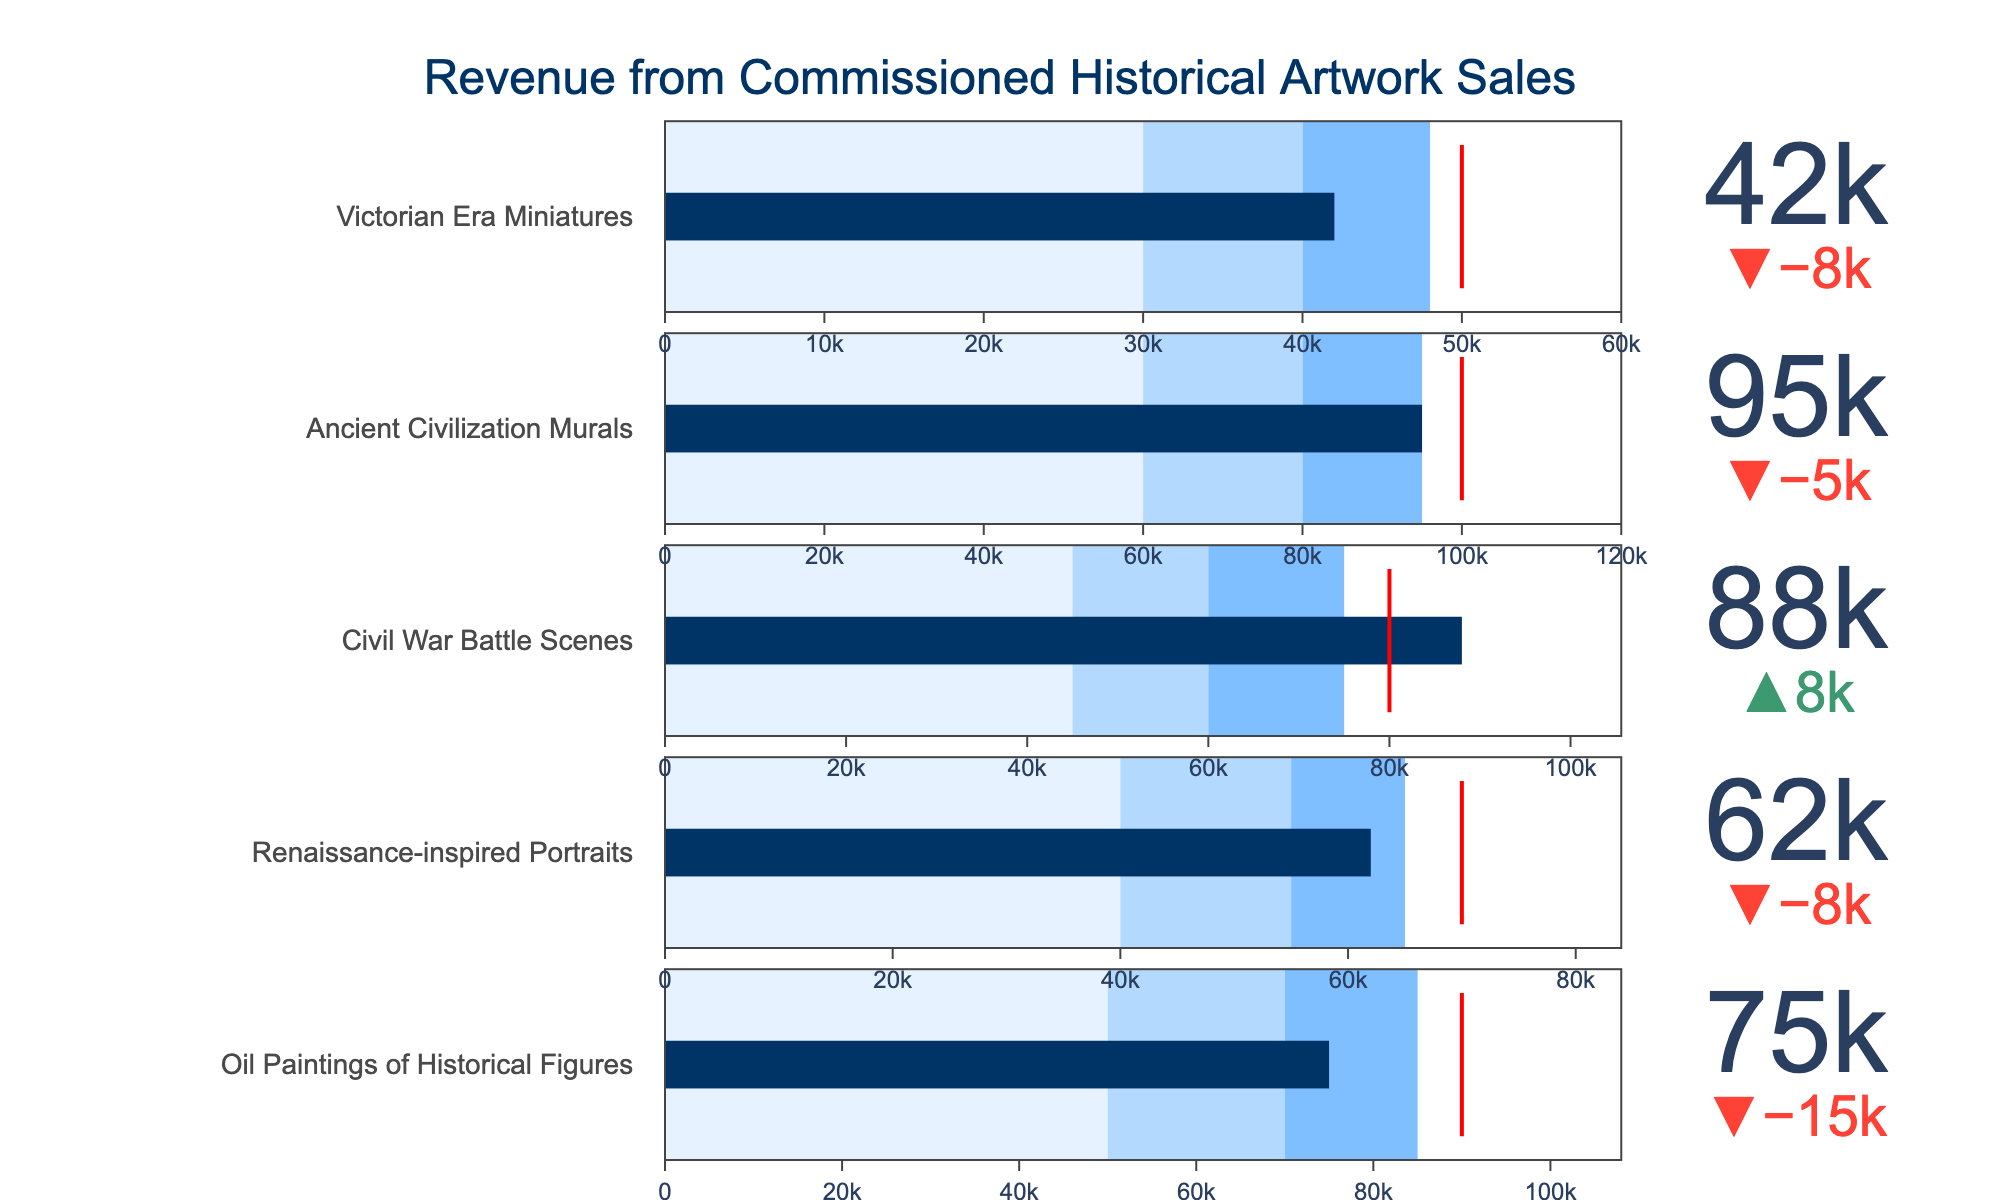What's the title of the chart? The title of the chart is a clear visual element usually found at the top. In this case, it's indicated in the 'update_layout' attributes.
Answer: "Revenue from Commissioned Historical Artwork Sales" How much actual revenue was generated from "Renaissance-inspired Portraits"? Each bullet chart represents a specific artwork title and its corresponding actual revenue value. For "Renaissance-inspired Portraits", the actual value is displayed on the bar.
Answer: 62000 What was the target revenue for "Ancient Civilization Murals"? The target revenue is indicated by a red line on each bullet graph. For "Ancient Civilization Murals", the figure will show this target clearly.
Answer: 100000 How does the actual revenue for "Victorian Era Miniatures" compare with its target revenue? To compare, look at both the actual bar value and the target (red line). For "Victorian Era Miniatures", checking these elements shows the actual and target values.
Answer: The actual revenue is 42000 and the target is 50000. The actual revenue is 8000 below the target Which artwork category surpassed its target revenue by the largest amount? First identify artwork categories that surpassed their target by comparing the actual value and the target value for each. Subtract the target from the actual revenue for these categories, the largest positive difference indicates the winner.
Answer: "Civil War Battle Scenes" surpassed by 8000 What's the range of moderate revenue for "Oil Paintings of Historical Figures"? The slightly darker shade on the bullet chart represents the moderate revenue range. From the figure, the moderate range (range2) can be observed.
Answer: 50000 to 70000 Which artwork category is closest to its target revenue but still falling short? Find the categories that haven't reached their target. Subtract the actual revenue from the target for these categories. The one with the smallest positive difference will be closest to its target.
Answer: "Renaissance-inspired Portraits" is 8000 short of its target How much more revenue does "Victorian Era Miniatures" need to reach the lower end of the highest performance range (range3)? Look at the highest performance range for "Victorian Era Miniatures". The lower end of this range is 48000. Subtract the actual revenue from this value.
Answer: 6000 Which artwork has the highest actual revenue? Check the actual revenue values displayed on the bars for each artwork and identify the maximum value.
Answer: "Ancient Civilization Murals" What percentage of the target revenue did "Civil War Battle Scenes" accomplish? Calculate the percentage by (Actual/Target) * 100 for "Civil War Battle Scenes". The actual revenue is 88000 and the target is 80000. So, (88000/80000) * 100.
Answer: 110% 